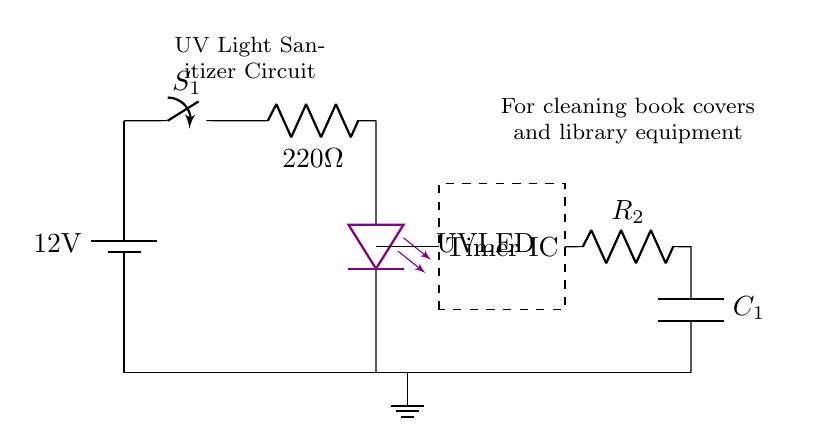What is the voltage of this circuit? The circuit is powered by a battery marked as 12V, indicating the voltage provided to the entire circuit.
Answer: 12V What type of component is labeled as "S1"? "S1" is identified as a switch in the circuit, which is a device used to break or complete an electrical circuit.
Answer: Switch What is the function of the resistor labeled "R1"? "R1" is a current limiting resistor, indicated by its placement before the UV LED. It limits the amount of current that flows through the LED to protect it from excess current.
Answer: Current limiting How is the timer integrated into the circuit? The timer is shown as a dashed rectangle around a labeled area in the circuit, indicating that it functions in conjunction with the surrounding components to control the timing of the UV LED.
Answer: Timer IC What is the resistance value of "R2"? The value of "R2" is not explicitly labeled in the provided information, but by examining the circuit structure, "R2" is located directly following the timer and is an element of the timing circuit; however, its specific value is not indicated visually.
Answer: Not specified What is the purpose of the capacitor labeled "C1"? "C1" is a capacitor used for timing in conjunction with resistor "R2"; together, they determine the duration for which the UV LED is activated, making it a critical element for the delay function of the timer.
Answer: Timing What color of light does the component labeled "UV LED" emit? The UV LED is specifically noted with the color violet, which indicates it emits ultraviolet light that is used for sanitizing purposes.
Answer: Violet 